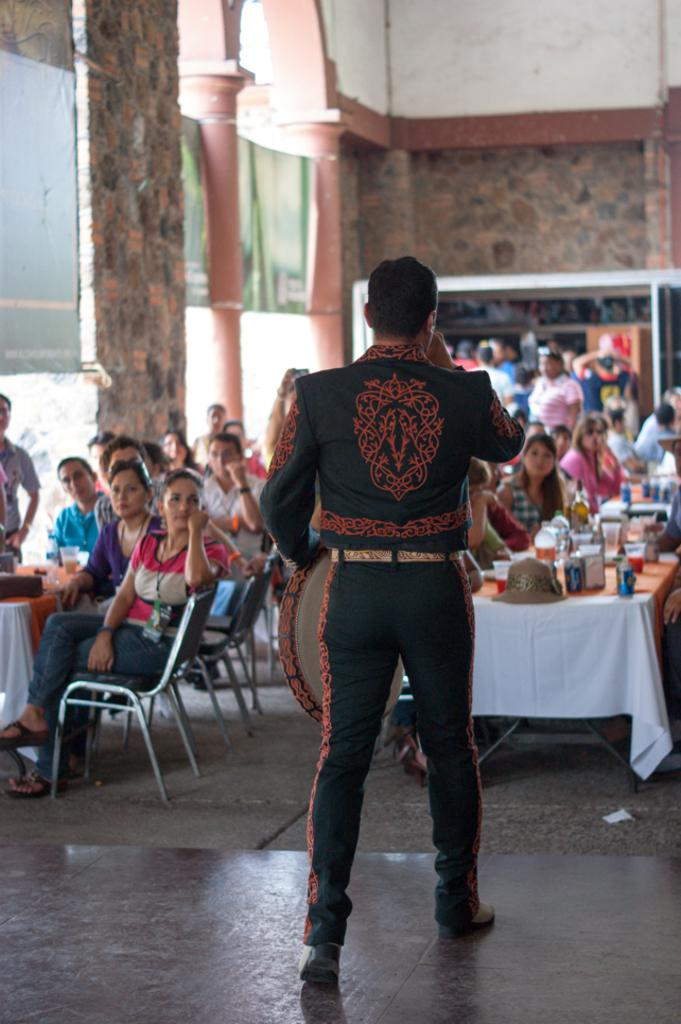What are the people in the image doing? The people in the image are sitting and standing. What can be seen on the tables in the image? There are objects placed on the tables in the image. What is visible in the background of the image? There is a wall and pillars in the background of the image. What type of yarn is being used by the minister in the image? There is no minister or yarn present in the image. How many sticks are visible in the image? There are no sticks visible in the image. 